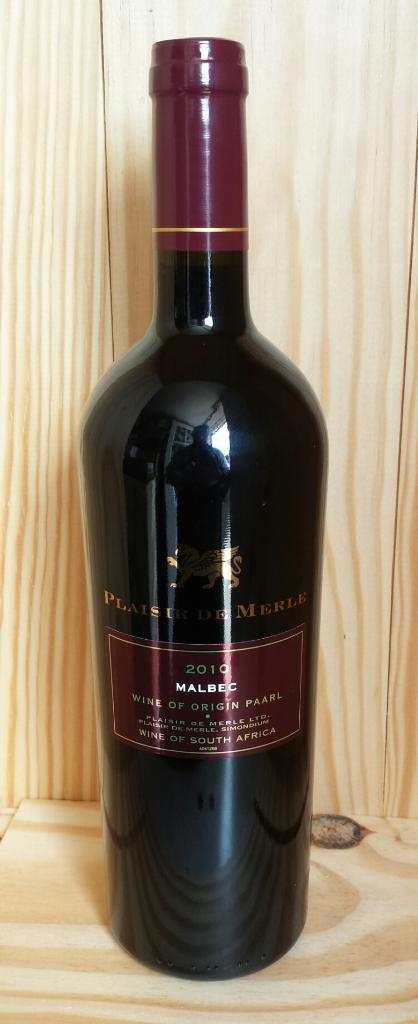What country is this wine from?
Your response must be concise. Unanswerable. When was this wine produced?
Keep it short and to the point. 2010. 